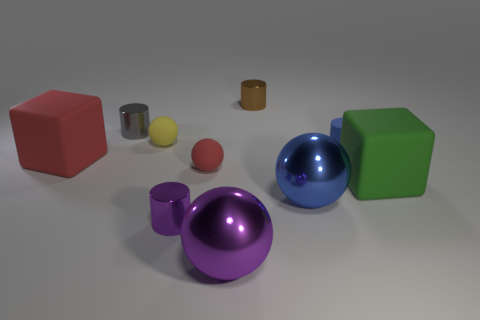Subtract all big purple metallic spheres. How many spheres are left? 3 Subtract 2 cylinders. How many cylinders are left? 2 Subtract all purple spheres. How many spheres are left? 3 Subtract all cubes. How many objects are left? 8 Subtract all purple cylinders. How many yellow balls are left? 1 Subtract 0 cyan balls. How many objects are left? 10 Subtract all cyan cubes. Subtract all blue cylinders. How many cubes are left? 2 Subtract all blue rubber cylinders. Subtract all blue matte objects. How many objects are left? 8 Add 3 large blue metallic spheres. How many large blue metallic spheres are left? 4 Add 7 cyan shiny spheres. How many cyan shiny spheres exist? 7 